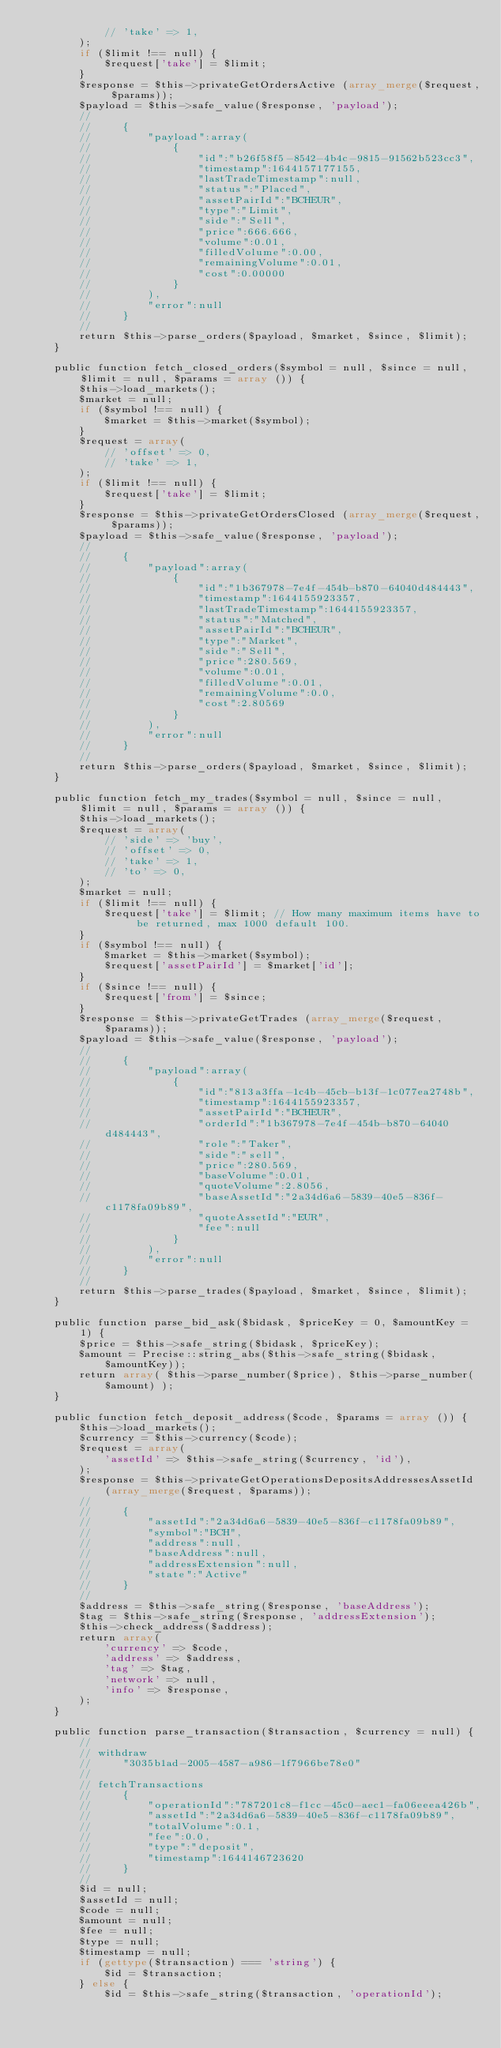<code> <loc_0><loc_0><loc_500><loc_500><_PHP_>            // 'take' => 1,
        );
        if ($limit !== null) {
            $request['take'] = $limit;
        }
        $response = $this->privateGetOrdersActive (array_merge($request, $params));
        $payload = $this->safe_value($response, 'payload');
        //
        //     {
        //         "payload":array(
        //             {
        //                 "id":"b26f58f5-8542-4b4c-9815-91562b523cc3",
        //                 "timestamp":1644157177155,
        //                 "lastTradeTimestamp":null,
        //                 "status":"Placed",
        //                 "assetPairId":"BCHEUR",
        //                 "type":"Limit",
        //                 "side":"Sell",
        //                 "price":666.666,
        //                 "volume":0.01,
        //                 "filledVolume":0.00,
        //                 "remainingVolume":0.01,
        //                 "cost":0.00000
        //             }
        //         ),
        //         "error":null
        //     }
        //
        return $this->parse_orders($payload, $market, $since, $limit);
    }

    public function fetch_closed_orders($symbol = null, $since = null, $limit = null, $params = array ()) {
        $this->load_markets();
        $market = null;
        if ($symbol !== null) {
            $market = $this->market($symbol);
        }
        $request = array(
            // 'offset' => 0,
            // 'take' => 1,
        );
        if ($limit !== null) {
            $request['take'] = $limit;
        }
        $response = $this->privateGetOrdersClosed (array_merge($request, $params));
        $payload = $this->safe_value($response, 'payload');
        //
        //     {
        //         "payload":array(
        //             {
        //                 "id":"1b367978-7e4f-454b-b870-64040d484443",
        //                 "timestamp":1644155923357,
        //                 "lastTradeTimestamp":1644155923357,
        //                 "status":"Matched",
        //                 "assetPairId":"BCHEUR",
        //                 "type":"Market",
        //                 "side":"Sell",
        //                 "price":280.569,
        //                 "volume":0.01,
        //                 "filledVolume":0.01,
        //                 "remainingVolume":0.0,
        //                 "cost":2.80569
        //             }
        //         ),
        //         "error":null
        //     }
        //
        return $this->parse_orders($payload, $market, $since, $limit);
    }

    public function fetch_my_trades($symbol = null, $since = null, $limit = null, $params = array ()) {
        $this->load_markets();
        $request = array(
            // 'side' => 'buy',
            // 'offset' => 0,
            // 'take' => 1,
            // 'to' => 0,
        );
        $market = null;
        if ($limit !== null) {
            $request['take'] = $limit; // How many maximum items have to be returned, max 1000 default 100.
        }
        if ($symbol !== null) {
            $market = $this->market($symbol);
            $request['assetPairId'] = $market['id'];
        }
        if ($since !== null) {
            $request['from'] = $since;
        }
        $response = $this->privateGetTrades (array_merge($request, $params));
        $payload = $this->safe_value($response, 'payload');
        //
        //     {
        //         "payload":array(
        //             {
        //                 "id":"813a3ffa-1c4b-45cb-b13f-1c077ea2748b",
        //                 "timestamp":1644155923357,
        //                 "assetPairId":"BCHEUR",
        //                 "orderId":"1b367978-7e4f-454b-b870-64040d484443",
        //                 "role":"Taker",
        //                 "side":"sell",
        //                 "price":280.569,
        //                 "baseVolume":0.01,
        //                 "quoteVolume":2.8056,
        //                 "baseAssetId":"2a34d6a6-5839-40e5-836f-c1178fa09b89",
        //                 "quoteAssetId":"EUR",
        //                 "fee":null
        //             }
        //         ),
        //         "error":null
        //     }
        //
        return $this->parse_trades($payload, $market, $since, $limit);
    }

    public function parse_bid_ask($bidask, $priceKey = 0, $amountKey = 1) {
        $price = $this->safe_string($bidask, $priceKey);
        $amount = Precise::string_abs($this->safe_string($bidask, $amountKey));
        return array( $this->parse_number($price), $this->parse_number($amount) );
    }

    public function fetch_deposit_address($code, $params = array ()) {
        $this->load_markets();
        $currency = $this->currency($code);
        $request = array(
            'assetId' => $this->safe_string($currency, 'id'),
        );
        $response = $this->privateGetOperationsDepositsAddressesAssetId (array_merge($request, $params));
        //
        //     {
        //         "assetId":"2a34d6a6-5839-40e5-836f-c1178fa09b89",
        //         "symbol":"BCH",
        //         "address":null,
        //         "baseAddress":null,
        //         "addressExtension":null,
        //         "state":"Active"
        //     }
        //
        $address = $this->safe_string($response, 'baseAddress');
        $tag = $this->safe_string($response, 'addressExtension');
        $this->check_address($address);
        return array(
            'currency' => $code,
            'address' => $address,
            'tag' => $tag,
            'network' => null,
            'info' => $response,
        );
    }

    public function parse_transaction($transaction, $currency = null) {
        //
        // withdraw
        //     "3035b1ad-2005-4587-a986-1f7966be78e0"
        //
        // fetchTransactions
        //     {
        //         "operationId":"787201c8-f1cc-45c0-aec1-fa06eeea426b",
        //         "assetId":"2a34d6a6-5839-40e5-836f-c1178fa09b89",
        //         "totalVolume":0.1,
        //         "fee":0.0,
        //         "type":"deposit",
        //         "timestamp":1644146723620
        //     }
        //
        $id = null;
        $assetId = null;
        $code = null;
        $amount = null;
        $fee = null;
        $type = null;
        $timestamp = null;
        if (gettype($transaction) === 'string') {
            $id = $transaction;
        } else {
            $id = $this->safe_string($transaction, 'operationId');</code> 